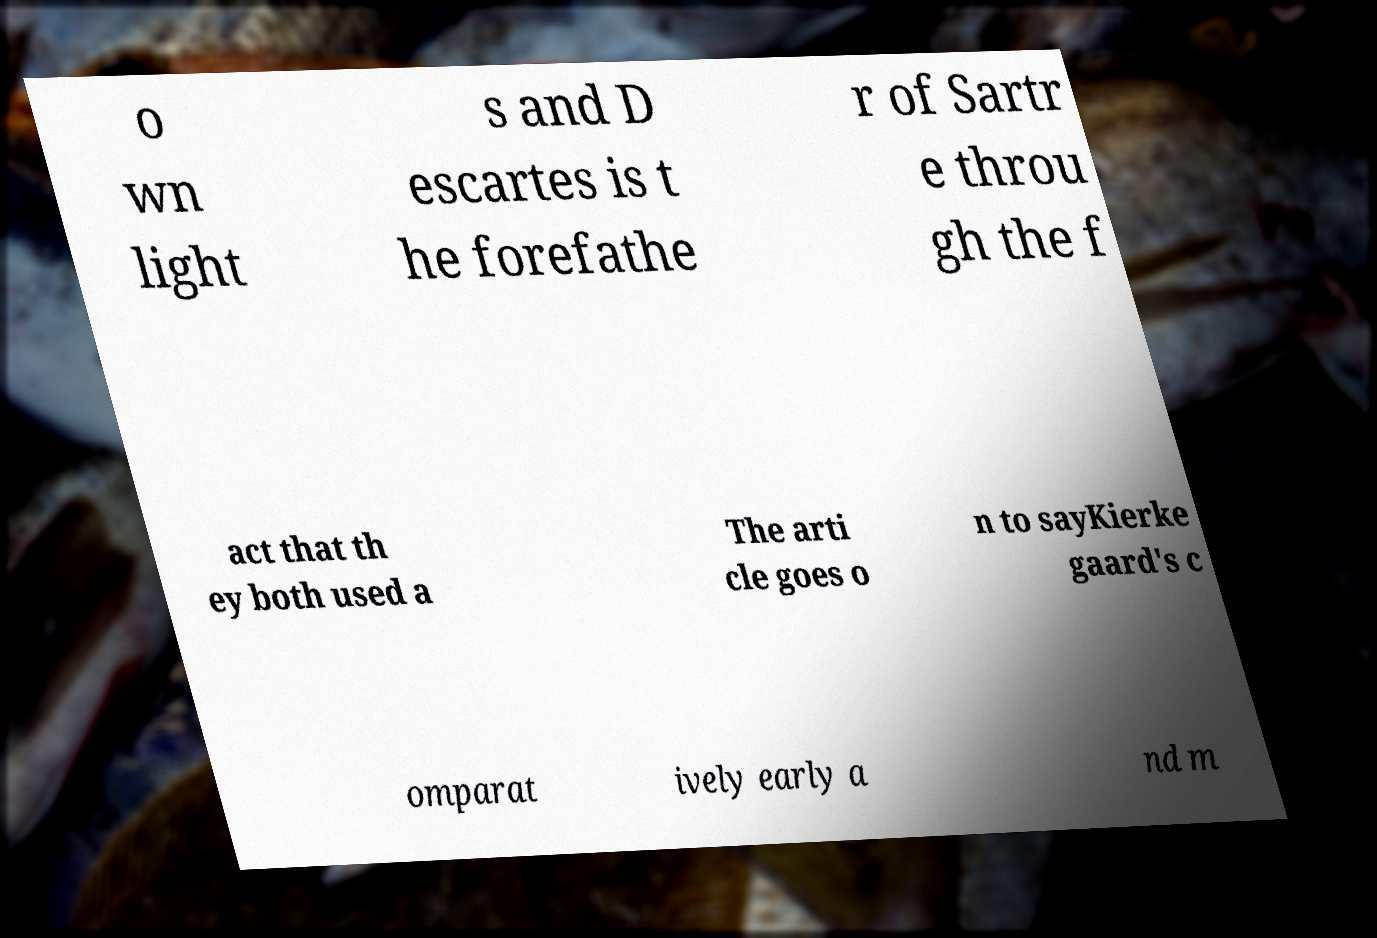Please read and relay the text visible in this image. What does it say? o wn light s and D escartes is t he forefathe r of Sartr e throu gh the f act that th ey both used a The arti cle goes o n to sayKierke gaard's c omparat ively early a nd m 